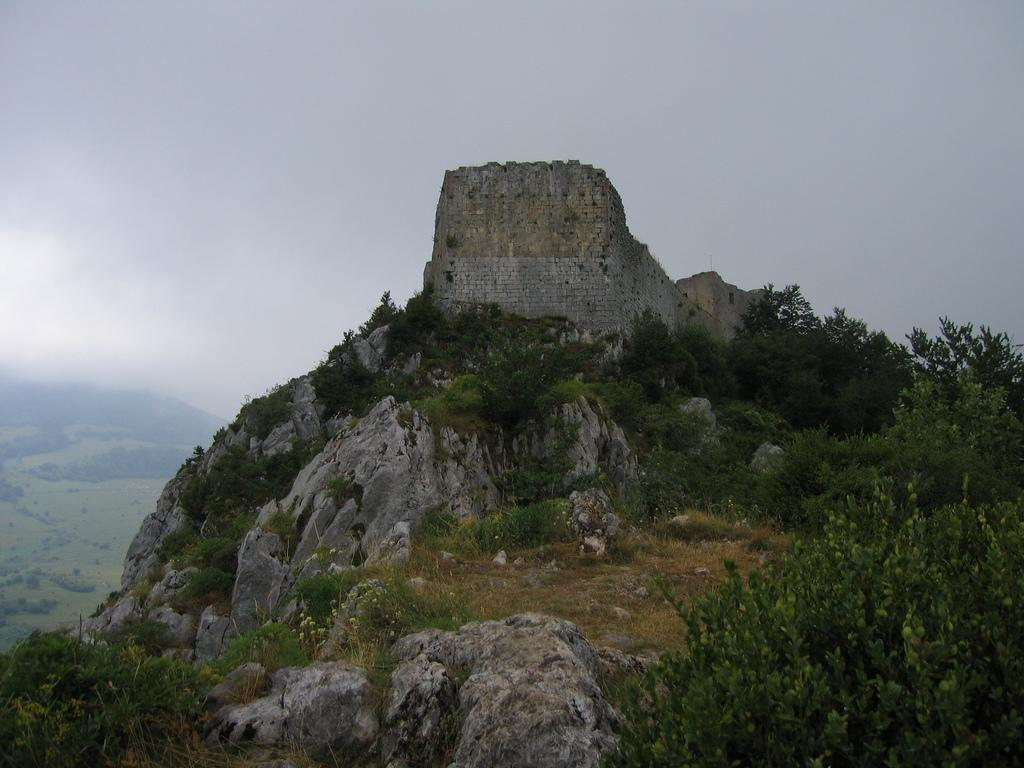What type of natural elements can be seen in the image? There are rocks and trees in the image. Can you describe the rocks in the image? The rocks in the image are likely part of the landscape or terrain. What type of vegetation is present in the image? There are trees in the image, which provide natural greenery. Where is the faucet located in the image? There is no faucet present in the image; it features rocks and trees. What type of fuel can be seen being used by the trees in the image? Trees do not use fuel; they produce their own energy through photosynthesis. 